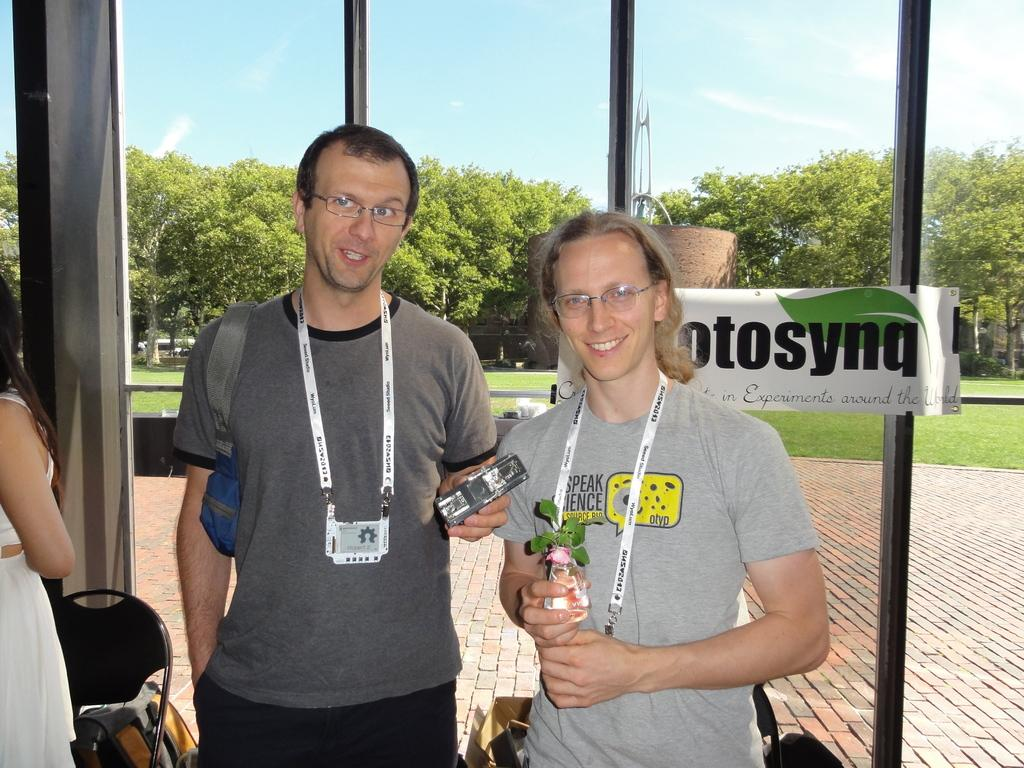How many people are in the image? There are two men in the image. What are the men wearing that can be seen in the image? The men are wearing ID cards. What is the background of the image? The men are standing in front of a glass wall, with trees and grass visible behind it. What is the condition of the sky in the image? The sky is filled with clouds in the image. What is the reaction of the men to the park in the image? There is no park present in the image, so it is not possible to determine their reaction to it. 